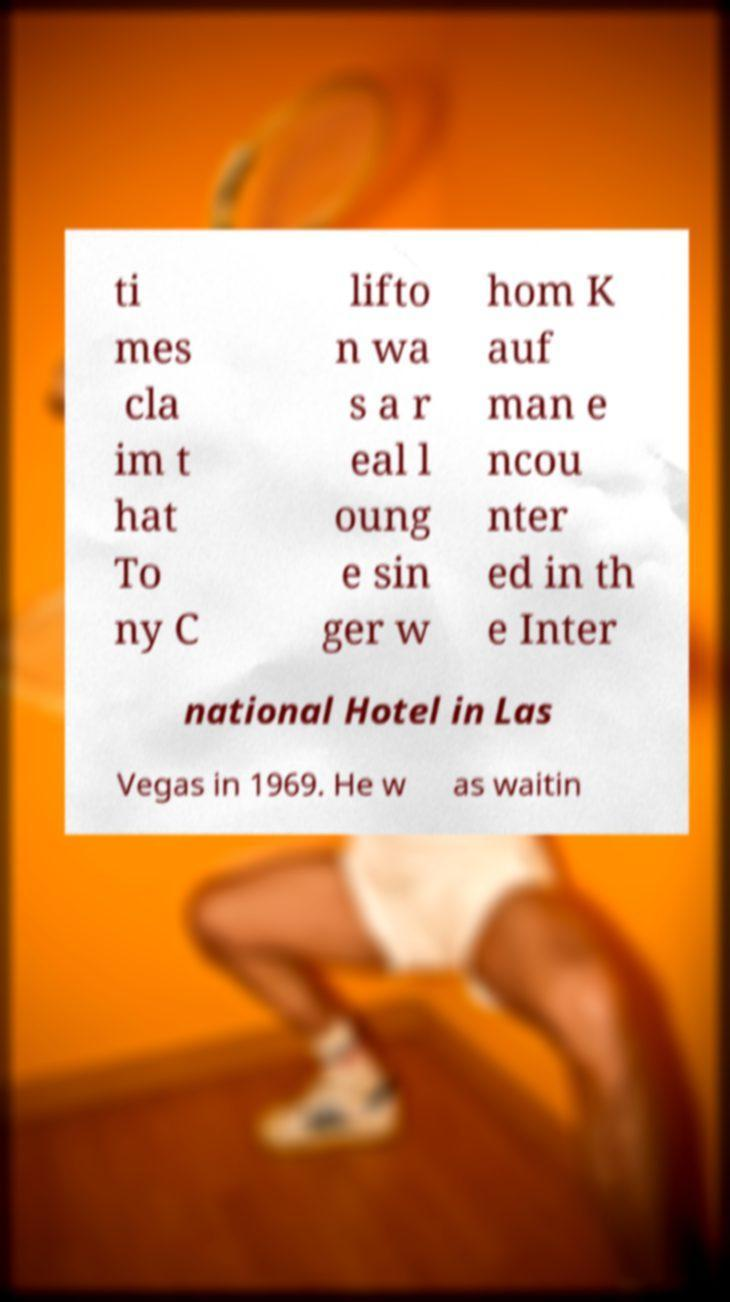Could you extract and type out the text from this image? ti mes cla im t hat To ny C lifto n wa s a r eal l oung e sin ger w hom K auf man e ncou nter ed in th e Inter national Hotel in Las Vegas in 1969. He w as waitin 